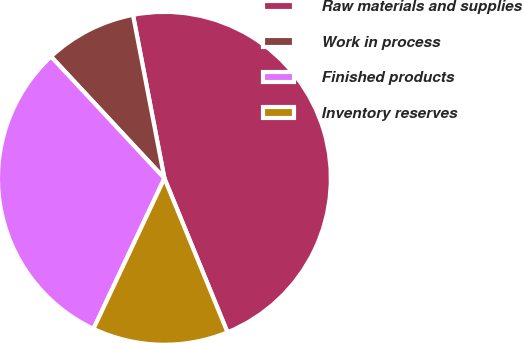Convert chart to OTSL. <chart><loc_0><loc_0><loc_500><loc_500><pie_chart><fcel>Raw materials and supplies<fcel>Work in process<fcel>Finished products<fcel>Inventory reserves<nl><fcel>46.84%<fcel>8.91%<fcel>31.06%<fcel>13.2%<nl></chart> 